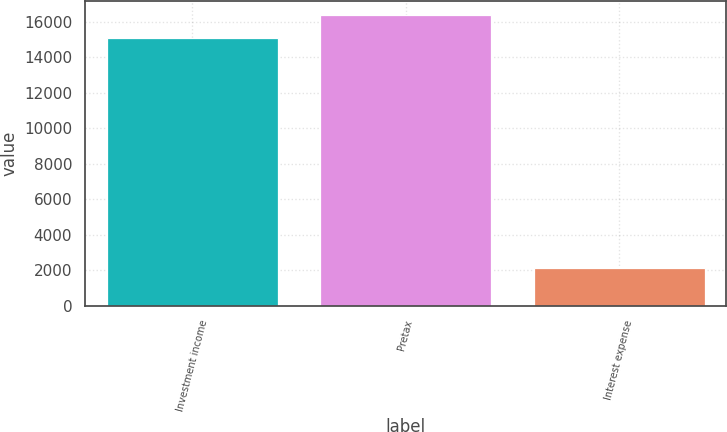Convert chart to OTSL. <chart><loc_0><loc_0><loc_500><loc_500><bar_chart><fcel>Investment income<fcel>Pretax<fcel>Interest expense<nl><fcel>15075<fcel>16369.7<fcel>2128<nl></chart> 